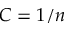<formula> <loc_0><loc_0><loc_500><loc_500>C = 1 / n</formula> 